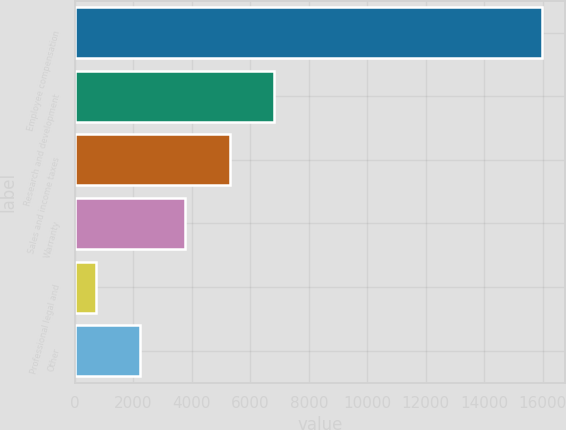Convert chart to OTSL. <chart><loc_0><loc_0><loc_500><loc_500><bar_chart><fcel>Employee compensation<fcel>Research and development<fcel>Sales and income taxes<fcel>Warranty<fcel>Professional legal and<fcel>Other<nl><fcel>15978<fcel>6817.2<fcel>5290.4<fcel>3763.6<fcel>710<fcel>2236.8<nl></chart> 